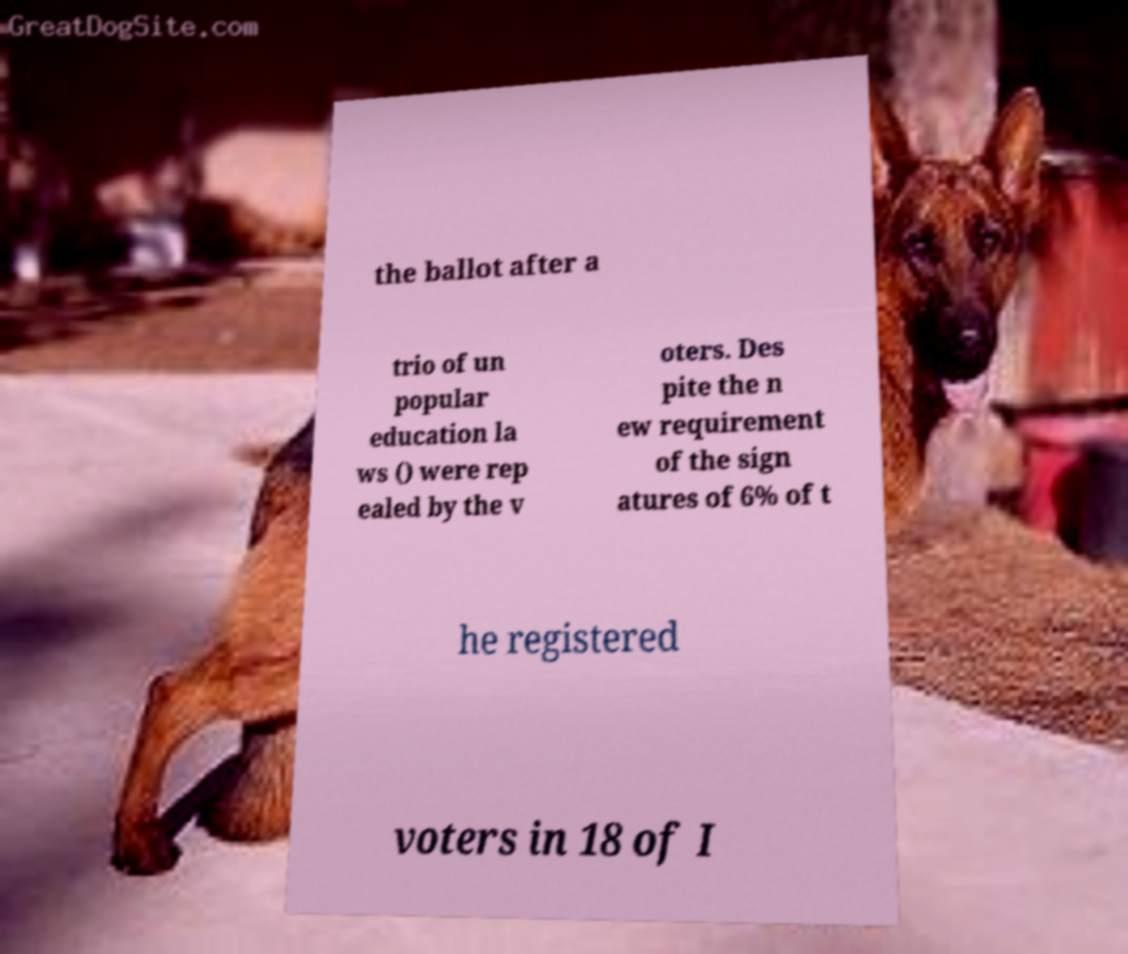Please identify and transcribe the text found in this image. the ballot after a trio of un popular education la ws () were rep ealed by the v oters. Des pite the n ew requirement of the sign atures of 6% of t he registered voters in 18 of I 